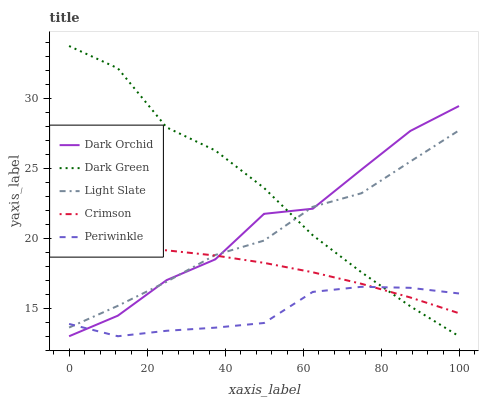Does Crimson have the minimum area under the curve?
Answer yes or no. No. Does Crimson have the maximum area under the curve?
Answer yes or no. No. Is Periwinkle the smoothest?
Answer yes or no. No. Is Periwinkle the roughest?
Answer yes or no. No. Does Crimson have the lowest value?
Answer yes or no. No. Does Crimson have the highest value?
Answer yes or no. No. 